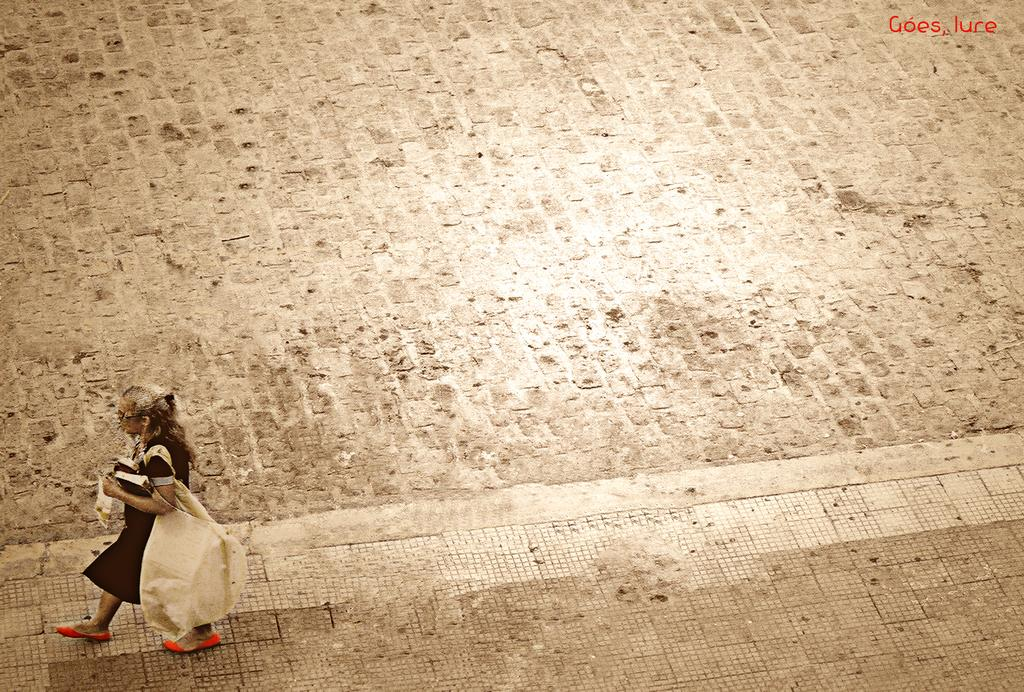Who or what is present in the image? There is a person in the image. What is the person holding or carrying? The person is carrying a bag. What can be seen beneath the person's feet? The ground is visible in the image. Is there any text or writing in the image? Yes, there is text in the top right corner of the image. How does the person feel about the comfort of the trains in the image? There are no trains present in the image, so it is not possible to determine how the person feels about their comfort. 